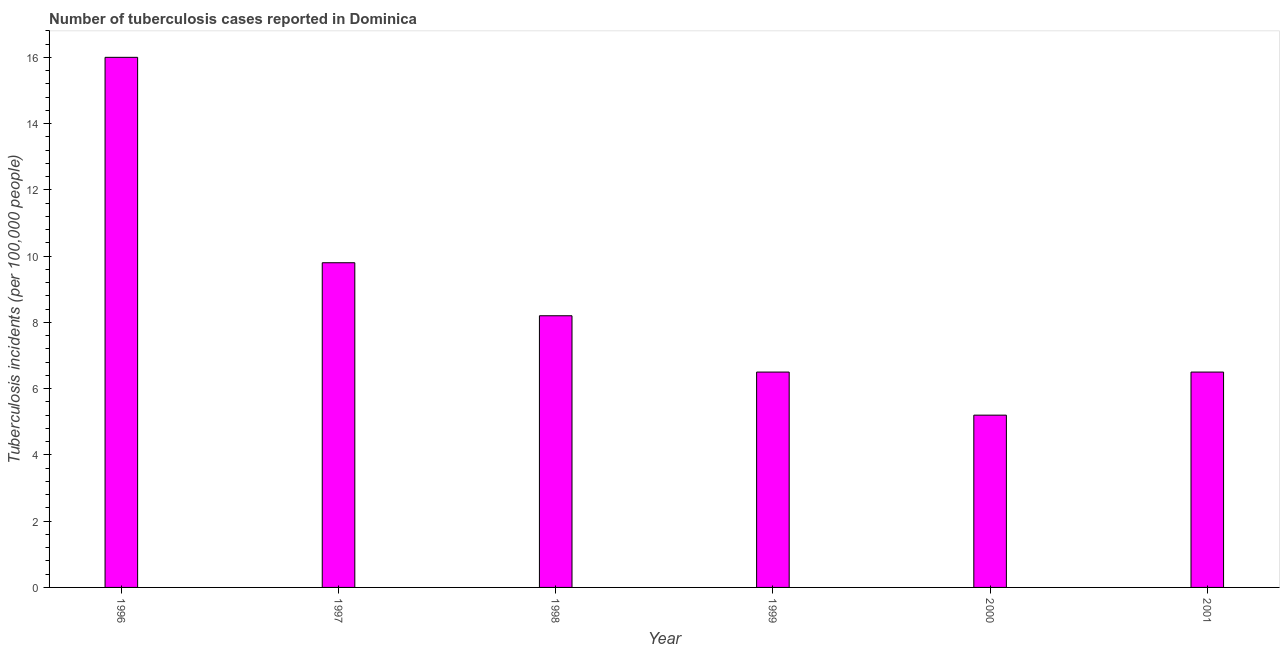What is the title of the graph?
Your answer should be compact. Number of tuberculosis cases reported in Dominica. What is the label or title of the X-axis?
Offer a very short reply. Year. What is the label or title of the Y-axis?
Make the answer very short. Tuberculosis incidents (per 100,0 people). What is the number of tuberculosis incidents in 2000?
Offer a very short reply. 5.2. Across all years, what is the minimum number of tuberculosis incidents?
Your answer should be very brief. 5.2. In which year was the number of tuberculosis incidents maximum?
Offer a terse response. 1996. In which year was the number of tuberculosis incidents minimum?
Give a very brief answer. 2000. What is the sum of the number of tuberculosis incidents?
Give a very brief answer. 52.2. What is the difference between the number of tuberculosis incidents in 1997 and 2000?
Your answer should be compact. 4.6. What is the median number of tuberculosis incidents?
Your answer should be compact. 7.35. In how many years, is the number of tuberculosis incidents greater than 4.4 ?
Your response must be concise. 6. Do a majority of the years between 2001 and 1996 (inclusive) have number of tuberculosis incidents greater than 6 ?
Keep it short and to the point. Yes. What is the ratio of the number of tuberculosis incidents in 1996 to that in 2000?
Give a very brief answer. 3.08. Is the number of tuberculosis incidents in 1997 less than that in 1998?
Give a very brief answer. No. In how many years, is the number of tuberculosis incidents greater than the average number of tuberculosis incidents taken over all years?
Offer a terse response. 2. Are all the bars in the graph horizontal?
Your response must be concise. No. Are the values on the major ticks of Y-axis written in scientific E-notation?
Offer a very short reply. No. What is the Tuberculosis incidents (per 100,000 people) of 1997?
Ensure brevity in your answer.  9.8. What is the Tuberculosis incidents (per 100,000 people) in 1998?
Your response must be concise. 8.2. What is the difference between the Tuberculosis incidents (per 100,000 people) in 1997 and 1998?
Provide a succinct answer. 1.6. What is the difference between the Tuberculosis incidents (per 100,000 people) in 1997 and 2001?
Provide a succinct answer. 3.3. What is the difference between the Tuberculosis incidents (per 100,000 people) in 1999 and 2000?
Your response must be concise. 1.3. What is the difference between the Tuberculosis incidents (per 100,000 people) in 1999 and 2001?
Make the answer very short. 0. What is the difference between the Tuberculosis incidents (per 100,000 people) in 2000 and 2001?
Your answer should be compact. -1.3. What is the ratio of the Tuberculosis incidents (per 100,000 people) in 1996 to that in 1997?
Provide a short and direct response. 1.63. What is the ratio of the Tuberculosis incidents (per 100,000 people) in 1996 to that in 1998?
Give a very brief answer. 1.95. What is the ratio of the Tuberculosis incidents (per 100,000 people) in 1996 to that in 1999?
Offer a terse response. 2.46. What is the ratio of the Tuberculosis incidents (per 100,000 people) in 1996 to that in 2000?
Give a very brief answer. 3.08. What is the ratio of the Tuberculosis incidents (per 100,000 people) in 1996 to that in 2001?
Provide a short and direct response. 2.46. What is the ratio of the Tuberculosis incidents (per 100,000 people) in 1997 to that in 1998?
Ensure brevity in your answer.  1.2. What is the ratio of the Tuberculosis incidents (per 100,000 people) in 1997 to that in 1999?
Make the answer very short. 1.51. What is the ratio of the Tuberculosis incidents (per 100,000 people) in 1997 to that in 2000?
Provide a succinct answer. 1.89. What is the ratio of the Tuberculosis incidents (per 100,000 people) in 1997 to that in 2001?
Ensure brevity in your answer.  1.51. What is the ratio of the Tuberculosis incidents (per 100,000 people) in 1998 to that in 1999?
Ensure brevity in your answer.  1.26. What is the ratio of the Tuberculosis incidents (per 100,000 people) in 1998 to that in 2000?
Give a very brief answer. 1.58. What is the ratio of the Tuberculosis incidents (per 100,000 people) in 1998 to that in 2001?
Provide a succinct answer. 1.26. What is the ratio of the Tuberculosis incidents (per 100,000 people) in 1999 to that in 2000?
Provide a short and direct response. 1.25. What is the ratio of the Tuberculosis incidents (per 100,000 people) in 1999 to that in 2001?
Your answer should be very brief. 1. 